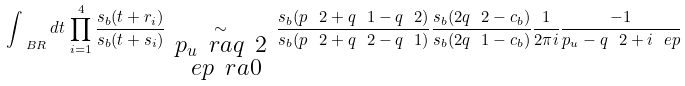Convert formula to latex. <formula><loc_0><loc_0><loc_500><loc_500>\int _ { \ B R } d t \, \prod _ { i = 1 } ^ { 4 } \frac { s _ { b } ( t + r _ { i } ) } { s _ { b } ( t + s _ { i } ) } \, \underset { \begin{smallmatrix} p _ { u } \ r a q _ { \ } 2 \\ \ e p \ r a 0 \end{smallmatrix} } { \sim } \, \frac { s _ { b } ( p _ { \ } 2 + q _ { \ } 1 - q _ { \ } 2 ) } { s _ { b } ( p _ { \ } 2 + q _ { \ } 2 - q _ { \ } 1 ) } \frac { s _ { b } ( 2 q _ { \ } 2 - c _ { b } ) } { s _ { b } ( 2 q _ { \ } 1 - c _ { b } ) } \frac { 1 } { 2 \pi i } \frac { - 1 } { p _ { u } - q _ { \ } 2 + i \ e p } \,</formula> 